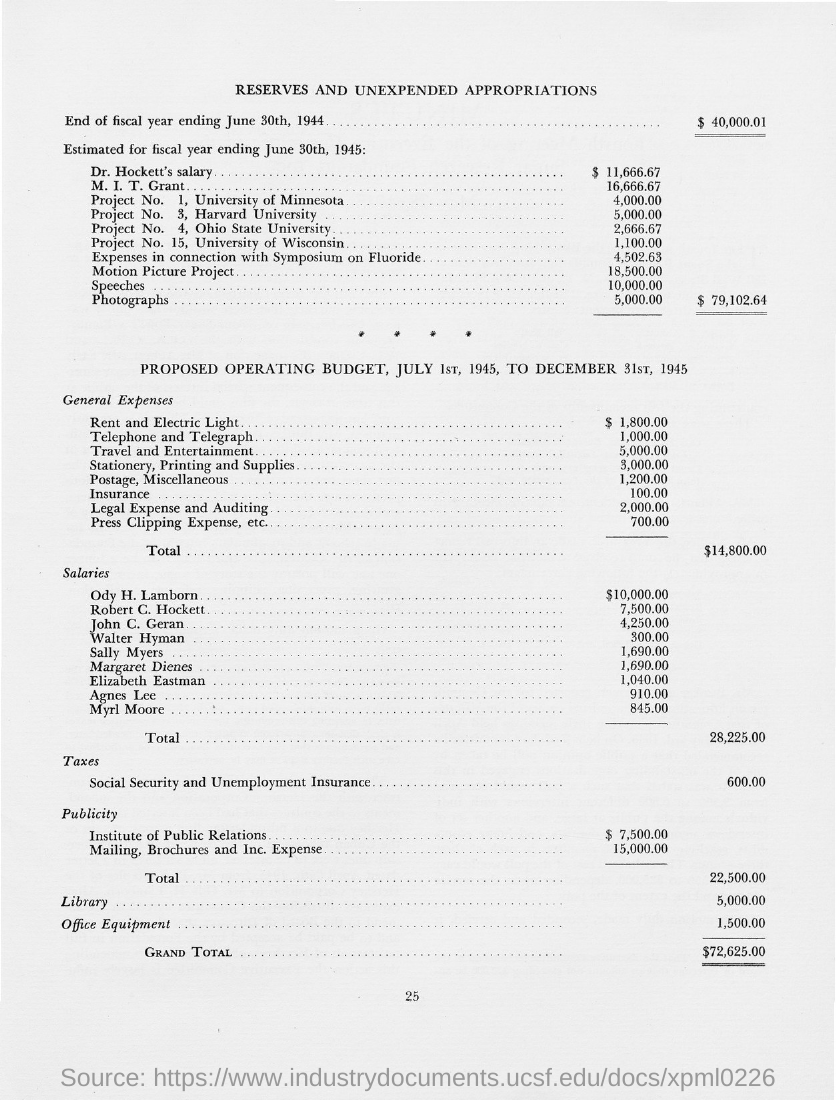Identify some key points in this picture. The grand total value is $72,625.00. The rental expenses for housing and electricity amount to $1,800.00. The page number on this document is 25. What is the title of this document? It is called RESERVES AND UNEXPENDED APPROPRIATIONS. The value of the end of the fiscal year ending on June 30th, 1944, was $40,000.01. 